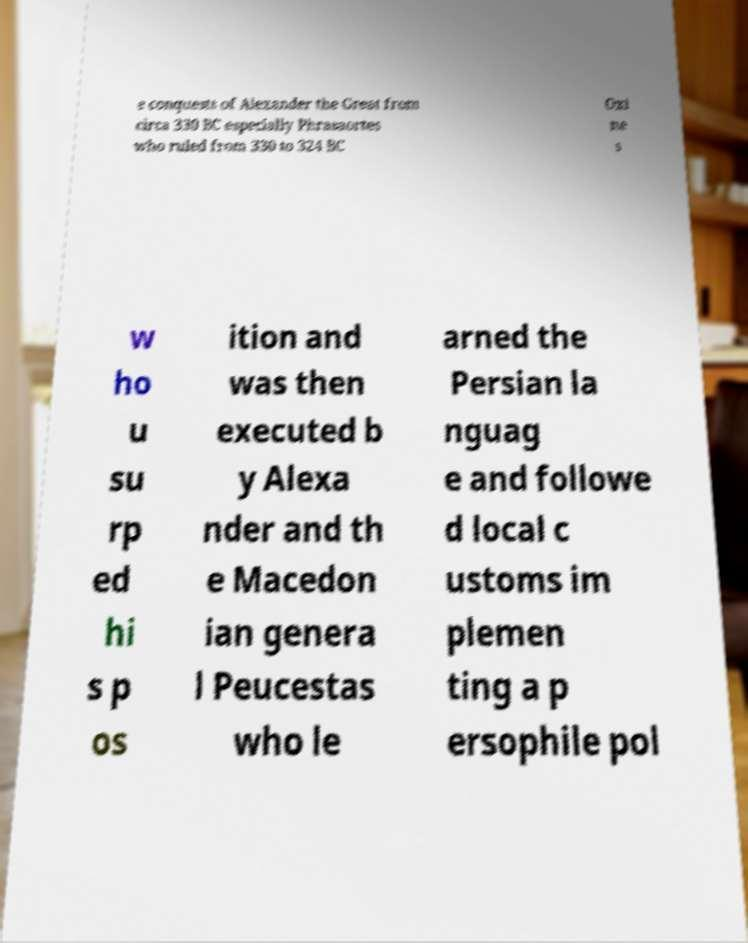Can you accurately transcribe the text from the provided image for me? e conquests of Alexander the Great from circa 330 BC especially Phrasaortes who ruled from 330 to 324 BC Oxi ne s w ho u su rp ed hi s p os ition and was then executed b y Alexa nder and th e Macedon ian genera l Peucestas who le arned the Persian la nguag e and followe d local c ustoms im plemen ting a p ersophile pol 